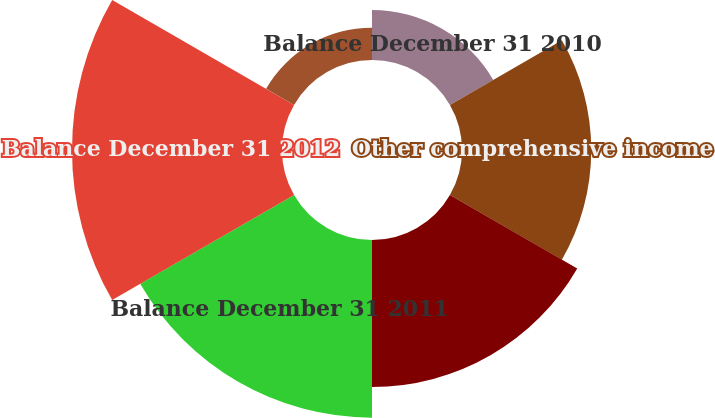Convert chart to OTSL. <chart><loc_0><loc_0><loc_500><loc_500><pie_chart><fcel>Balance December 31 2010<fcel>Other comprehensive income<fcel>Net current period other<fcel>Balance December 31 2011<fcel>Balance December 31 2012<fcel>Balance December 31 2013<nl><fcel>6.71%<fcel>17.32%<fcel>19.7%<fcel>23.81%<fcel>28.14%<fcel>4.33%<nl></chart> 